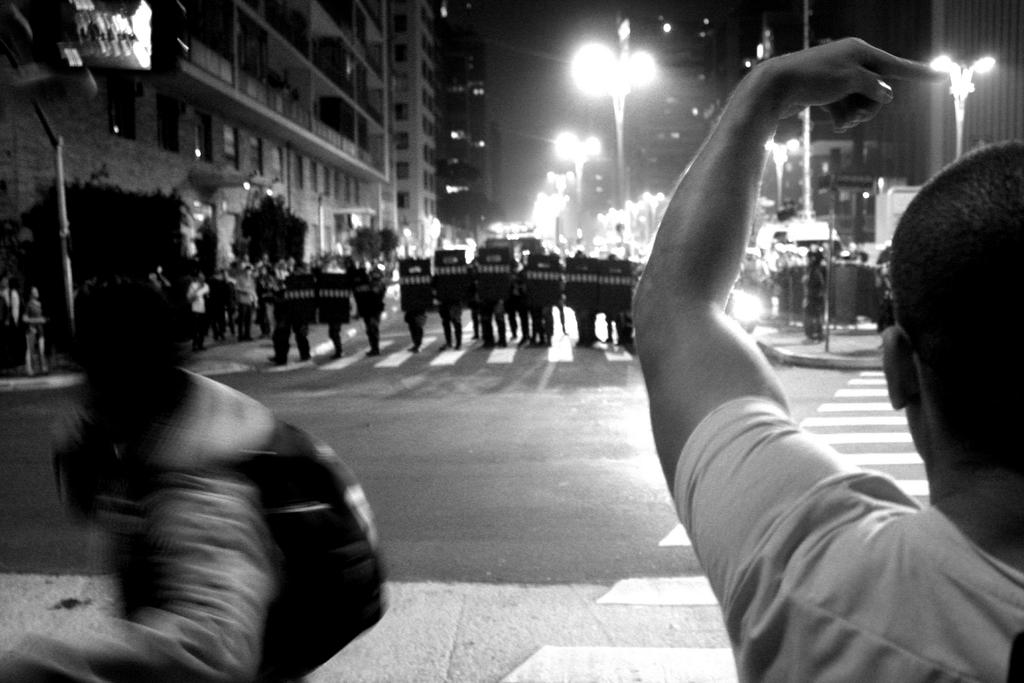What is happening on the road in the image? There are people on the road in the image. What are the people holding on the road? The people are holding metal objects. What can be seen along the road in the image? There are light poles in the image. What else can be seen in the image besides the road? There are people on the walkway and buildings visible in the image. What type of trouble is the thumb causing in the image? There is no thumb present in the image, so it cannot cause any trouble. Is there a battle taking place in the image? There is no battle depicted in the image; it shows people on the road and walkway, light poles, and buildings. 